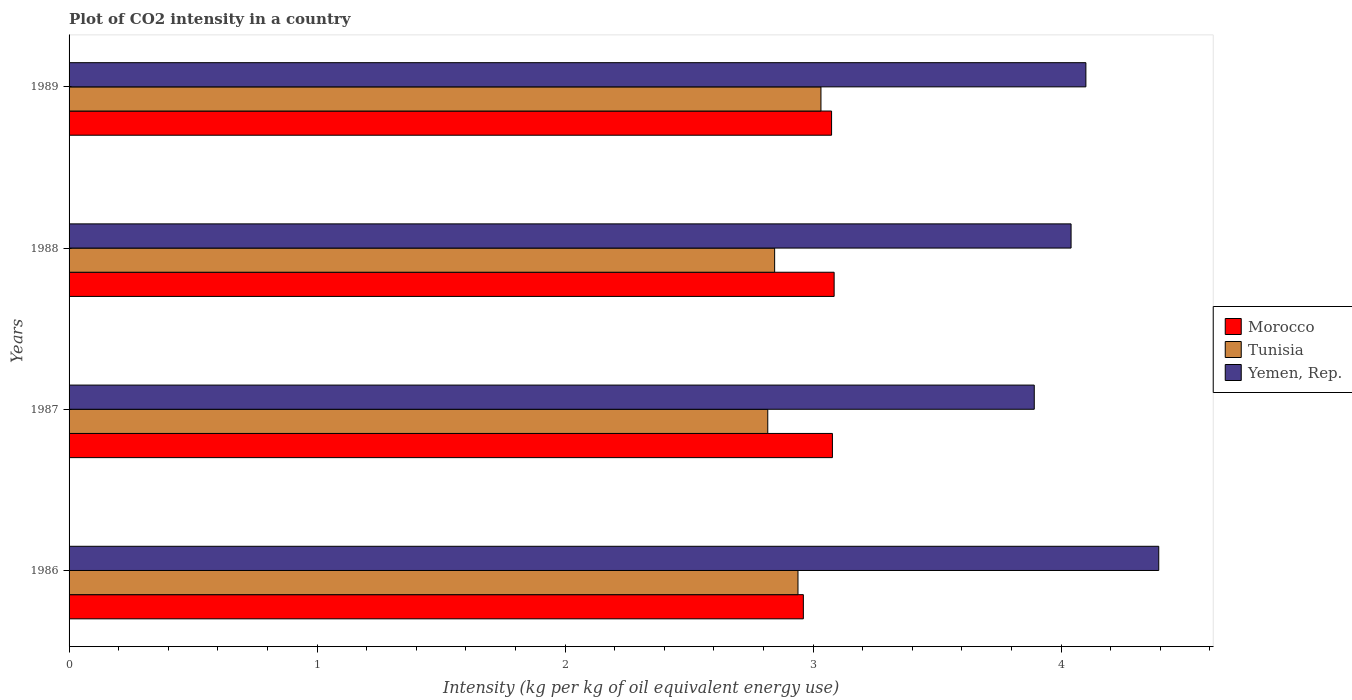How many different coloured bars are there?
Your response must be concise. 3. How many groups of bars are there?
Ensure brevity in your answer.  4. How many bars are there on the 3rd tick from the top?
Keep it short and to the point. 3. What is the CO2 intensity in in Tunisia in 1987?
Your answer should be very brief. 2.82. Across all years, what is the maximum CO2 intensity in in Morocco?
Ensure brevity in your answer.  3.09. Across all years, what is the minimum CO2 intensity in in Tunisia?
Provide a succinct answer. 2.82. In which year was the CO2 intensity in in Tunisia maximum?
Make the answer very short. 1989. What is the total CO2 intensity in in Morocco in the graph?
Offer a very short reply. 12.2. What is the difference between the CO2 intensity in in Yemen, Rep. in 1987 and that in 1989?
Give a very brief answer. -0.21. What is the difference between the CO2 intensity in in Morocco in 1989 and the CO2 intensity in in Yemen, Rep. in 1986?
Ensure brevity in your answer.  -1.32. What is the average CO2 intensity in in Tunisia per year?
Keep it short and to the point. 2.91. In the year 1986, what is the difference between the CO2 intensity in in Tunisia and CO2 intensity in in Yemen, Rep.?
Offer a terse response. -1.45. What is the ratio of the CO2 intensity in in Yemen, Rep. in 1988 to that in 1989?
Provide a short and direct response. 0.99. Is the CO2 intensity in in Morocco in 1986 less than that in 1988?
Make the answer very short. Yes. Is the difference between the CO2 intensity in in Tunisia in 1987 and 1988 greater than the difference between the CO2 intensity in in Yemen, Rep. in 1987 and 1988?
Make the answer very short. Yes. What is the difference between the highest and the second highest CO2 intensity in in Tunisia?
Offer a terse response. 0.09. What is the difference between the highest and the lowest CO2 intensity in in Morocco?
Make the answer very short. 0.12. In how many years, is the CO2 intensity in in Yemen, Rep. greater than the average CO2 intensity in in Yemen, Rep. taken over all years?
Your response must be concise. 1. Is the sum of the CO2 intensity in in Tunisia in 1988 and 1989 greater than the maximum CO2 intensity in in Morocco across all years?
Make the answer very short. Yes. What does the 2nd bar from the top in 1989 represents?
Your answer should be compact. Tunisia. What does the 1st bar from the bottom in 1989 represents?
Your response must be concise. Morocco. Is it the case that in every year, the sum of the CO2 intensity in in Yemen, Rep. and CO2 intensity in in Tunisia is greater than the CO2 intensity in in Morocco?
Your answer should be very brief. Yes. Are all the bars in the graph horizontal?
Ensure brevity in your answer.  Yes. How are the legend labels stacked?
Make the answer very short. Vertical. What is the title of the graph?
Ensure brevity in your answer.  Plot of CO2 intensity in a country. Does "Mali" appear as one of the legend labels in the graph?
Ensure brevity in your answer.  No. What is the label or title of the X-axis?
Provide a short and direct response. Intensity (kg per kg of oil equivalent energy use). What is the label or title of the Y-axis?
Provide a short and direct response. Years. What is the Intensity (kg per kg of oil equivalent energy use) in Morocco in 1986?
Ensure brevity in your answer.  2.96. What is the Intensity (kg per kg of oil equivalent energy use) of Tunisia in 1986?
Keep it short and to the point. 2.94. What is the Intensity (kg per kg of oil equivalent energy use) of Yemen, Rep. in 1986?
Your response must be concise. 4.39. What is the Intensity (kg per kg of oil equivalent energy use) of Morocco in 1987?
Your answer should be compact. 3.08. What is the Intensity (kg per kg of oil equivalent energy use) in Tunisia in 1987?
Offer a very short reply. 2.82. What is the Intensity (kg per kg of oil equivalent energy use) in Yemen, Rep. in 1987?
Provide a succinct answer. 3.89. What is the Intensity (kg per kg of oil equivalent energy use) in Morocco in 1988?
Your response must be concise. 3.09. What is the Intensity (kg per kg of oil equivalent energy use) in Tunisia in 1988?
Provide a succinct answer. 2.85. What is the Intensity (kg per kg of oil equivalent energy use) of Yemen, Rep. in 1988?
Your answer should be very brief. 4.04. What is the Intensity (kg per kg of oil equivalent energy use) in Morocco in 1989?
Make the answer very short. 3.07. What is the Intensity (kg per kg of oil equivalent energy use) in Tunisia in 1989?
Offer a very short reply. 3.03. What is the Intensity (kg per kg of oil equivalent energy use) in Yemen, Rep. in 1989?
Offer a terse response. 4.1. Across all years, what is the maximum Intensity (kg per kg of oil equivalent energy use) in Morocco?
Keep it short and to the point. 3.09. Across all years, what is the maximum Intensity (kg per kg of oil equivalent energy use) of Tunisia?
Offer a terse response. 3.03. Across all years, what is the maximum Intensity (kg per kg of oil equivalent energy use) in Yemen, Rep.?
Offer a very short reply. 4.39. Across all years, what is the minimum Intensity (kg per kg of oil equivalent energy use) in Morocco?
Offer a very short reply. 2.96. Across all years, what is the minimum Intensity (kg per kg of oil equivalent energy use) of Tunisia?
Provide a succinct answer. 2.82. Across all years, what is the minimum Intensity (kg per kg of oil equivalent energy use) of Yemen, Rep.?
Ensure brevity in your answer.  3.89. What is the total Intensity (kg per kg of oil equivalent energy use) of Morocco in the graph?
Ensure brevity in your answer.  12.2. What is the total Intensity (kg per kg of oil equivalent energy use) in Tunisia in the graph?
Make the answer very short. 11.63. What is the total Intensity (kg per kg of oil equivalent energy use) in Yemen, Rep. in the graph?
Your answer should be compact. 16.43. What is the difference between the Intensity (kg per kg of oil equivalent energy use) in Morocco in 1986 and that in 1987?
Provide a succinct answer. -0.12. What is the difference between the Intensity (kg per kg of oil equivalent energy use) of Tunisia in 1986 and that in 1987?
Your response must be concise. 0.12. What is the difference between the Intensity (kg per kg of oil equivalent energy use) in Yemen, Rep. in 1986 and that in 1987?
Offer a very short reply. 0.5. What is the difference between the Intensity (kg per kg of oil equivalent energy use) of Morocco in 1986 and that in 1988?
Provide a succinct answer. -0.12. What is the difference between the Intensity (kg per kg of oil equivalent energy use) of Tunisia in 1986 and that in 1988?
Your response must be concise. 0.09. What is the difference between the Intensity (kg per kg of oil equivalent energy use) of Yemen, Rep. in 1986 and that in 1988?
Ensure brevity in your answer.  0.35. What is the difference between the Intensity (kg per kg of oil equivalent energy use) in Morocco in 1986 and that in 1989?
Offer a very short reply. -0.11. What is the difference between the Intensity (kg per kg of oil equivalent energy use) of Tunisia in 1986 and that in 1989?
Your response must be concise. -0.09. What is the difference between the Intensity (kg per kg of oil equivalent energy use) of Yemen, Rep. in 1986 and that in 1989?
Provide a succinct answer. 0.29. What is the difference between the Intensity (kg per kg of oil equivalent energy use) of Morocco in 1987 and that in 1988?
Keep it short and to the point. -0.01. What is the difference between the Intensity (kg per kg of oil equivalent energy use) of Tunisia in 1987 and that in 1988?
Your answer should be compact. -0.03. What is the difference between the Intensity (kg per kg of oil equivalent energy use) of Yemen, Rep. in 1987 and that in 1988?
Provide a succinct answer. -0.15. What is the difference between the Intensity (kg per kg of oil equivalent energy use) of Morocco in 1987 and that in 1989?
Provide a succinct answer. 0. What is the difference between the Intensity (kg per kg of oil equivalent energy use) in Tunisia in 1987 and that in 1989?
Your response must be concise. -0.21. What is the difference between the Intensity (kg per kg of oil equivalent energy use) in Yemen, Rep. in 1987 and that in 1989?
Ensure brevity in your answer.  -0.21. What is the difference between the Intensity (kg per kg of oil equivalent energy use) in Morocco in 1988 and that in 1989?
Make the answer very short. 0.01. What is the difference between the Intensity (kg per kg of oil equivalent energy use) in Tunisia in 1988 and that in 1989?
Ensure brevity in your answer.  -0.19. What is the difference between the Intensity (kg per kg of oil equivalent energy use) in Yemen, Rep. in 1988 and that in 1989?
Provide a succinct answer. -0.06. What is the difference between the Intensity (kg per kg of oil equivalent energy use) in Morocco in 1986 and the Intensity (kg per kg of oil equivalent energy use) in Tunisia in 1987?
Provide a succinct answer. 0.14. What is the difference between the Intensity (kg per kg of oil equivalent energy use) of Morocco in 1986 and the Intensity (kg per kg of oil equivalent energy use) of Yemen, Rep. in 1987?
Make the answer very short. -0.93. What is the difference between the Intensity (kg per kg of oil equivalent energy use) of Tunisia in 1986 and the Intensity (kg per kg of oil equivalent energy use) of Yemen, Rep. in 1987?
Offer a terse response. -0.95. What is the difference between the Intensity (kg per kg of oil equivalent energy use) of Morocco in 1986 and the Intensity (kg per kg of oil equivalent energy use) of Tunisia in 1988?
Offer a very short reply. 0.12. What is the difference between the Intensity (kg per kg of oil equivalent energy use) of Morocco in 1986 and the Intensity (kg per kg of oil equivalent energy use) of Yemen, Rep. in 1988?
Make the answer very short. -1.08. What is the difference between the Intensity (kg per kg of oil equivalent energy use) of Tunisia in 1986 and the Intensity (kg per kg of oil equivalent energy use) of Yemen, Rep. in 1988?
Offer a very short reply. -1.1. What is the difference between the Intensity (kg per kg of oil equivalent energy use) of Morocco in 1986 and the Intensity (kg per kg of oil equivalent energy use) of Tunisia in 1989?
Provide a short and direct response. -0.07. What is the difference between the Intensity (kg per kg of oil equivalent energy use) in Morocco in 1986 and the Intensity (kg per kg of oil equivalent energy use) in Yemen, Rep. in 1989?
Give a very brief answer. -1.14. What is the difference between the Intensity (kg per kg of oil equivalent energy use) in Tunisia in 1986 and the Intensity (kg per kg of oil equivalent energy use) in Yemen, Rep. in 1989?
Your answer should be very brief. -1.16. What is the difference between the Intensity (kg per kg of oil equivalent energy use) in Morocco in 1987 and the Intensity (kg per kg of oil equivalent energy use) in Tunisia in 1988?
Provide a succinct answer. 0.23. What is the difference between the Intensity (kg per kg of oil equivalent energy use) of Morocco in 1987 and the Intensity (kg per kg of oil equivalent energy use) of Yemen, Rep. in 1988?
Your answer should be compact. -0.96. What is the difference between the Intensity (kg per kg of oil equivalent energy use) in Tunisia in 1987 and the Intensity (kg per kg of oil equivalent energy use) in Yemen, Rep. in 1988?
Keep it short and to the point. -1.22. What is the difference between the Intensity (kg per kg of oil equivalent energy use) of Morocco in 1987 and the Intensity (kg per kg of oil equivalent energy use) of Tunisia in 1989?
Your answer should be compact. 0.05. What is the difference between the Intensity (kg per kg of oil equivalent energy use) in Morocco in 1987 and the Intensity (kg per kg of oil equivalent energy use) in Yemen, Rep. in 1989?
Make the answer very short. -1.02. What is the difference between the Intensity (kg per kg of oil equivalent energy use) in Tunisia in 1987 and the Intensity (kg per kg of oil equivalent energy use) in Yemen, Rep. in 1989?
Your answer should be very brief. -1.28. What is the difference between the Intensity (kg per kg of oil equivalent energy use) in Morocco in 1988 and the Intensity (kg per kg of oil equivalent energy use) in Tunisia in 1989?
Offer a terse response. 0.05. What is the difference between the Intensity (kg per kg of oil equivalent energy use) of Morocco in 1988 and the Intensity (kg per kg of oil equivalent energy use) of Yemen, Rep. in 1989?
Your answer should be very brief. -1.02. What is the difference between the Intensity (kg per kg of oil equivalent energy use) in Tunisia in 1988 and the Intensity (kg per kg of oil equivalent energy use) in Yemen, Rep. in 1989?
Offer a very short reply. -1.26. What is the average Intensity (kg per kg of oil equivalent energy use) of Morocco per year?
Offer a terse response. 3.05. What is the average Intensity (kg per kg of oil equivalent energy use) in Tunisia per year?
Provide a succinct answer. 2.91. What is the average Intensity (kg per kg of oil equivalent energy use) in Yemen, Rep. per year?
Offer a terse response. 4.11. In the year 1986, what is the difference between the Intensity (kg per kg of oil equivalent energy use) in Morocco and Intensity (kg per kg of oil equivalent energy use) in Tunisia?
Give a very brief answer. 0.02. In the year 1986, what is the difference between the Intensity (kg per kg of oil equivalent energy use) of Morocco and Intensity (kg per kg of oil equivalent energy use) of Yemen, Rep.?
Offer a terse response. -1.43. In the year 1986, what is the difference between the Intensity (kg per kg of oil equivalent energy use) in Tunisia and Intensity (kg per kg of oil equivalent energy use) in Yemen, Rep.?
Your answer should be compact. -1.45. In the year 1987, what is the difference between the Intensity (kg per kg of oil equivalent energy use) of Morocco and Intensity (kg per kg of oil equivalent energy use) of Tunisia?
Your response must be concise. 0.26. In the year 1987, what is the difference between the Intensity (kg per kg of oil equivalent energy use) in Morocco and Intensity (kg per kg of oil equivalent energy use) in Yemen, Rep.?
Provide a short and direct response. -0.81. In the year 1987, what is the difference between the Intensity (kg per kg of oil equivalent energy use) in Tunisia and Intensity (kg per kg of oil equivalent energy use) in Yemen, Rep.?
Your answer should be compact. -1.07. In the year 1988, what is the difference between the Intensity (kg per kg of oil equivalent energy use) in Morocco and Intensity (kg per kg of oil equivalent energy use) in Tunisia?
Give a very brief answer. 0.24. In the year 1988, what is the difference between the Intensity (kg per kg of oil equivalent energy use) in Morocco and Intensity (kg per kg of oil equivalent energy use) in Yemen, Rep.?
Provide a succinct answer. -0.96. In the year 1988, what is the difference between the Intensity (kg per kg of oil equivalent energy use) of Tunisia and Intensity (kg per kg of oil equivalent energy use) of Yemen, Rep.?
Offer a terse response. -1.2. In the year 1989, what is the difference between the Intensity (kg per kg of oil equivalent energy use) of Morocco and Intensity (kg per kg of oil equivalent energy use) of Tunisia?
Keep it short and to the point. 0.04. In the year 1989, what is the difference between the Intensity (kg per kg of oil equivalent energy use) of Morocco and Intensity (kg per kg of oil equivalent energy use) of Yemen, Rep.?
Offer a terse response. -1.03. In the year 1989, what is the difference between the Intensity (kg per kg of oil equivalent energy use) in Tunisia and Intensity (kg per kg of oil equivalent energy use) in Yemen, Rep.?
Give a very brief answer. -1.07. What is the ratio of the Intensity (kg per kg of oil equivalent energy use) of Morocco in 1986 to that in 1987?
Your answer should be very brief. 0.96. What is the ratio of the Intensity (kg per kg of oil equivalent energy use) of Tunisia in 1986 to that in 1987?
Provide a short and direct response. 1.04. What is the ratio of the Intensity (kg per kg of oil equivalent energy use) in Yemen, Rep. in 1986 to that in 1987?
Offer a terse response. 1.13. What is the ratio of the Intensity (kg per kg of oil equivalent energy use) in Morocco in 1986 to that in 1988?
Your answer should be compact. 0.96. What is the ratio of the Intensity (kg per kg of oil equivalent energy use) in Tunisia in 1986 to that in 1988?
Your response must be concise. 1.03. What is the ratio of the Intensity (kg per kg of oil equivalent energy use) of Yemen, Rep. in 1986 to that in 1988?
Keep it short and to the point. 1.09. What is the ratio of the Intensity (kg per kg of oil equivalent energy use) in Morocco in 1986 to that in 1989?
Provide a short and direct response. 0.96. What is the ratio of the Intensity (kg per kg of oil equivalent energy use) in Tunisia in 1986 to that in 1989?
Your response must be concise. 0.97. What is the ratio of the Intensity (kg per kg of oil equivalent energy use) of Yemen, Rep. in 1986 to that in 1989?
Your response must be concise. 1.07. What is the ratio of the Intensity (kg per kg of oil equivalent energy use) of Tunisia in 1987 to that in 1988?
Offer a very short reply. 0.99. What is the ratio of the Intensity (kg per kg of oil equivalent energy use) of Yemen, Rep. in 1987 to that in 1988?
Your answer should be compact. 0.96. What is the ratio of the Intensity (kg per kg of oil equivalent energy use) of Morocco in 1987 to that in 1989?
Give a very brief answer. 1. What is the ratio of the Intensity (kg per kg of oil equivalent energy use) in Tunisia in 1987 to that in 1989?
Provide a short and direct response. 0.93. What is the ratio of the Intensity (kg per kg of oil equivalent energy use) in Yemen, Rep. in 1987 to that in 1989?
Make the answer very short. 0.95. What is the ratio of the Intensity (kg per kg of oil equivalent energy use) in Tunisia in 1988 to that in 1989?
Your response must be concise. 0.94. What is the ratio of the Intensity (kg per kg of oil equivalent energy use) of Yemen, Rep. in 1988 to that in 1989?
Your response must be concise. 0.99. What is the difference between the highest and the second highest Intensity (kg per kg of oil equivalent energy use) of Morocco?
Keep it short and to the point. 0.01. What is the difference between the highest and the second highest Intensity (kg per kg of oil equivalent energy use) of Tunisia?
Provide a succinct answer. 0.09. What is the difference between the highest and the second highest Intensity (kg per kg of oil equivalent energy use) in Yemen, Rep.?
Provide a short and direct response. 0.29. What is the difference between the highest and the lowest Intensity (kg per kg of oil equivalent energy use) in Morocco?
Your response must be concise. 0.12. What is the difference between the highest and the lowest Intensity (kg per kg of oil equivalent energy use) of Tunisia?
Your answer should be compact. 0.21. What is the difference between the highest and the lowest Intensity (kg per kg of oil equivalent energy use) of Yemen, Rep.?
Keep it short and to the point. 0.5. 